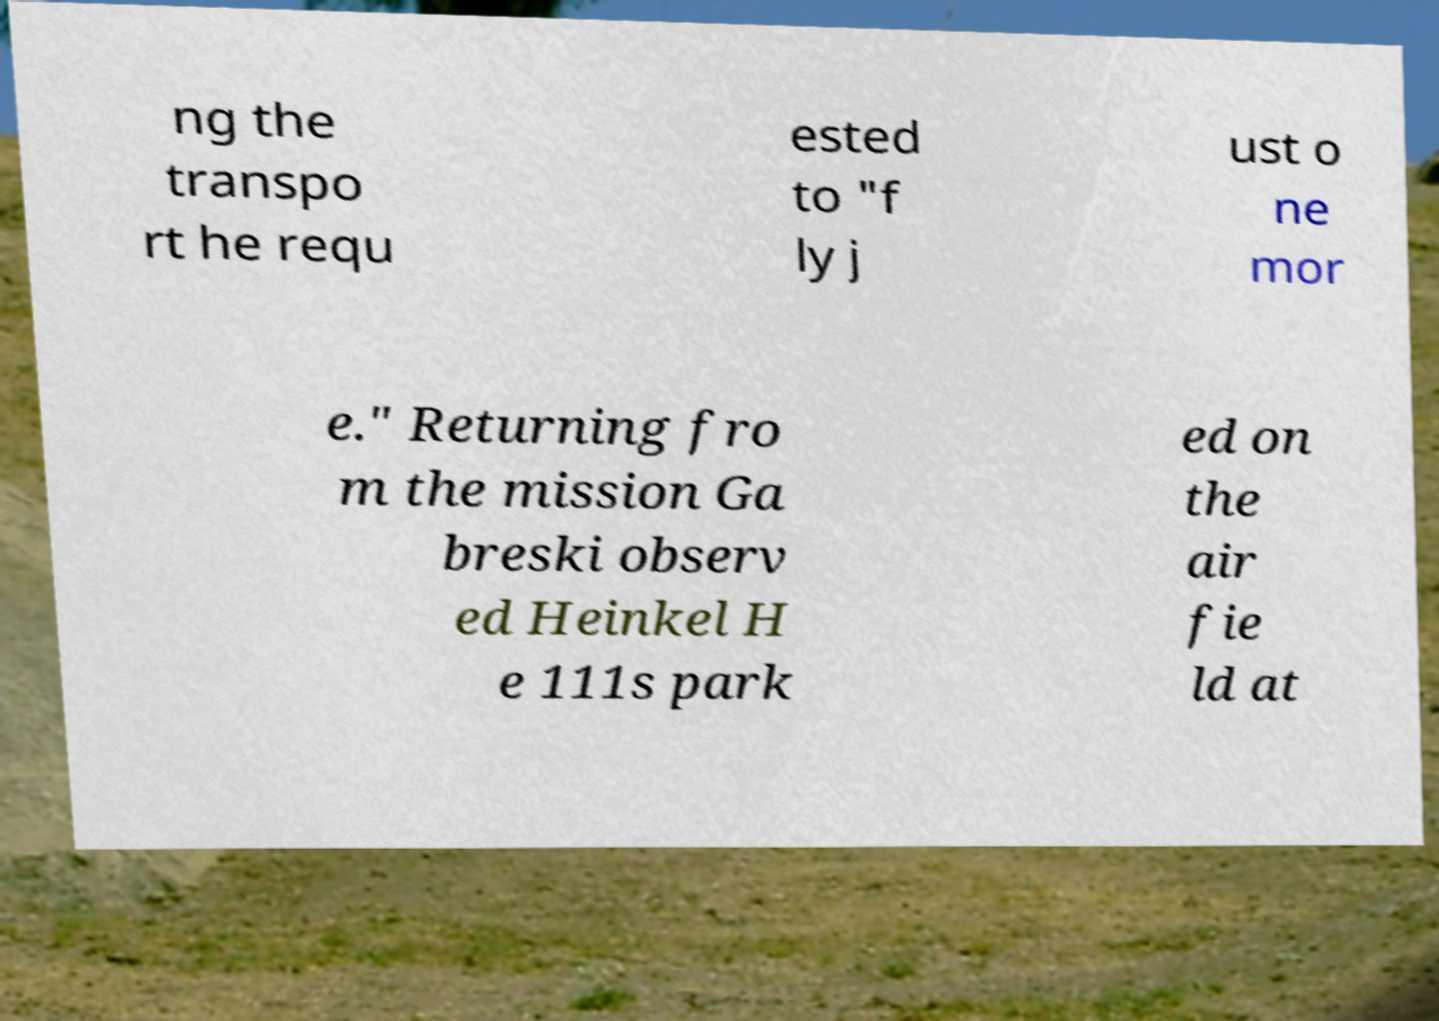I need the written content from this picture converted into text. Can you do that? ng the transpo rt he requ ested to "f ly j ust o ne mor e." Returning fro m the mission Ga breski observ ed Heinkel H e 111s park ed on the air fie ld at 